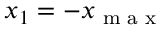<formula> <loc_0><loc_0><loc_500><loc_500>x _ { 1 } = - x _ { \max }</formula> 